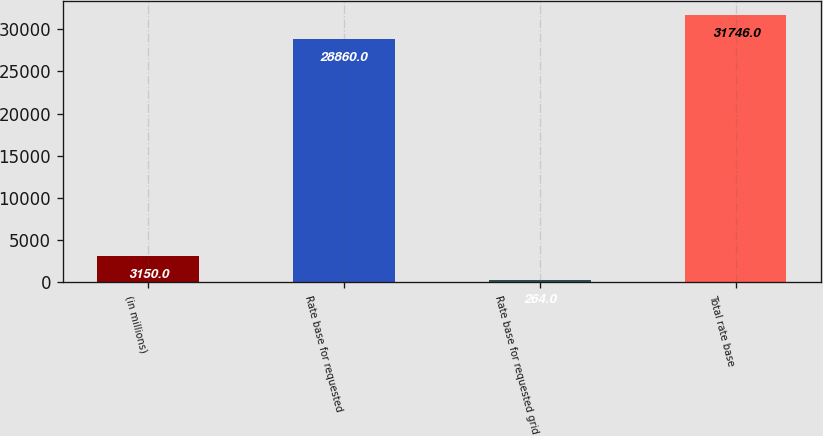<chart> <loc_0><loc_0><loc_500><loc_500><bar_chart><fcel>(in millions)<fcel>Rate base for requested<fcel>Rate base for requested grid<fcel>Total rate base<nl><fcel>3150<fcel>28860<fcel>264<fcel>31746<nl></chart> 